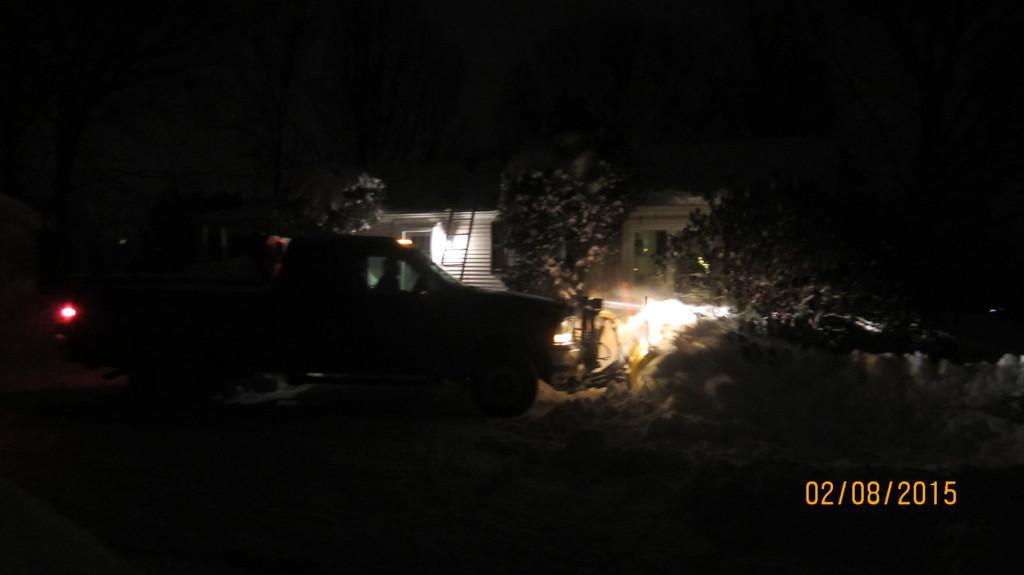Could you give a brief overview of what you see in this image? In the image we can see a vehicle, building, ladder, light, grass, tree and a watermark. 